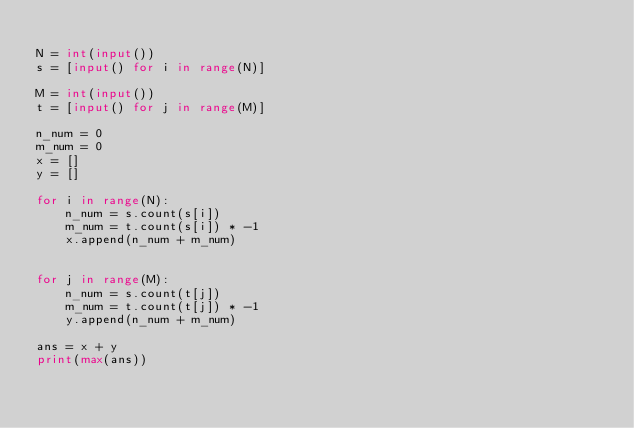Convert code to text. <code><loc_0><loc_0><loc_500><loc_500><_Python_>
N = int(input())
s = [input() for i in range(N)]

M = int(input())
t = [input() for j in range(M)]

n_num = 0
m_num = 0
x = []
y = []

for i in range(N):
    n_num = s.count(s[i])
    m_num = t.count(s[i]) * -1
    x.append(n_num + m_num)


for j in range(M):
    n_num = s.count(t[j])
    m_num = t.count(t[j]) * -1
    y.append(n_num + m_num)

ans = x + y
print(max(ans))
</code> 